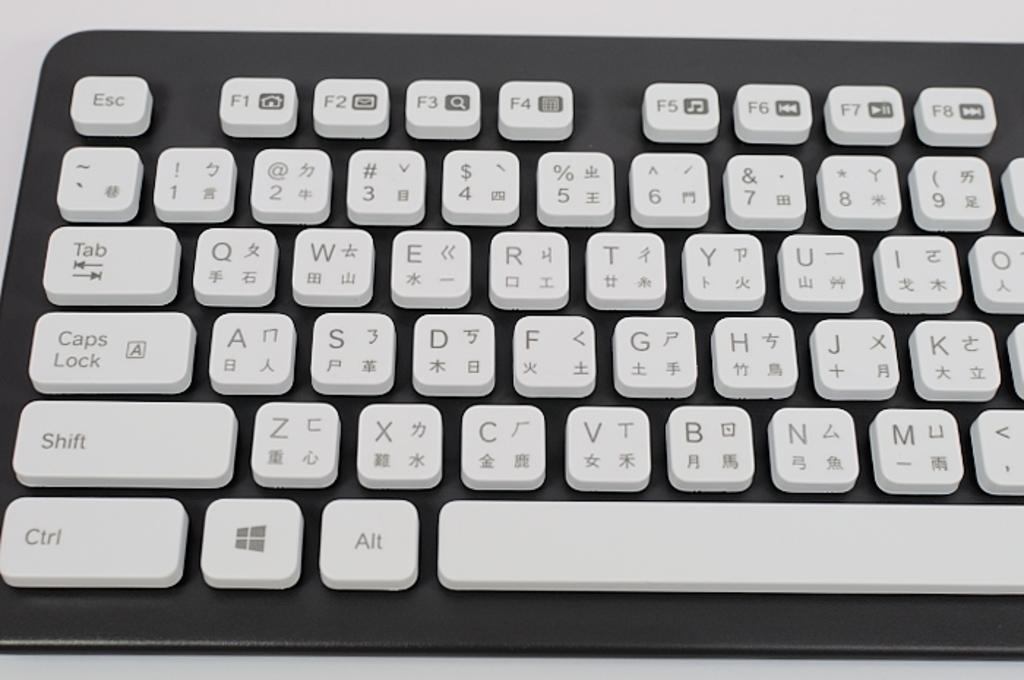<image>
Offer a succinct explanation of the picture presented. a chinese keyboard that has both chinese and english on it. 